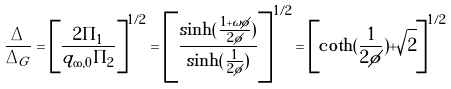Convert formula to latex. <formula><loc_0><loc_0><loc_500><loc_500>\frac { \Delta } { \Delta _ { G } } = \left [ \frac { 2 \Pi _ { 1 } } { q _ { \infty , 0 } \Pi _ { 2 } } \right ] ^ { 1 / 2 } = \left [ \frac { \sinh ( \frac { 1 + \omega \phi } { 2 \phi } ) } { \sinh ( \frac { 1 } { 2 \phi } ) } \right ] ^ { 1 / 2 } = \left [ \coth ( \frac { 1 } { 2 \phi } ) + \sqrt { 2 } \right ] ^ { 1 / 2 }</formula> 